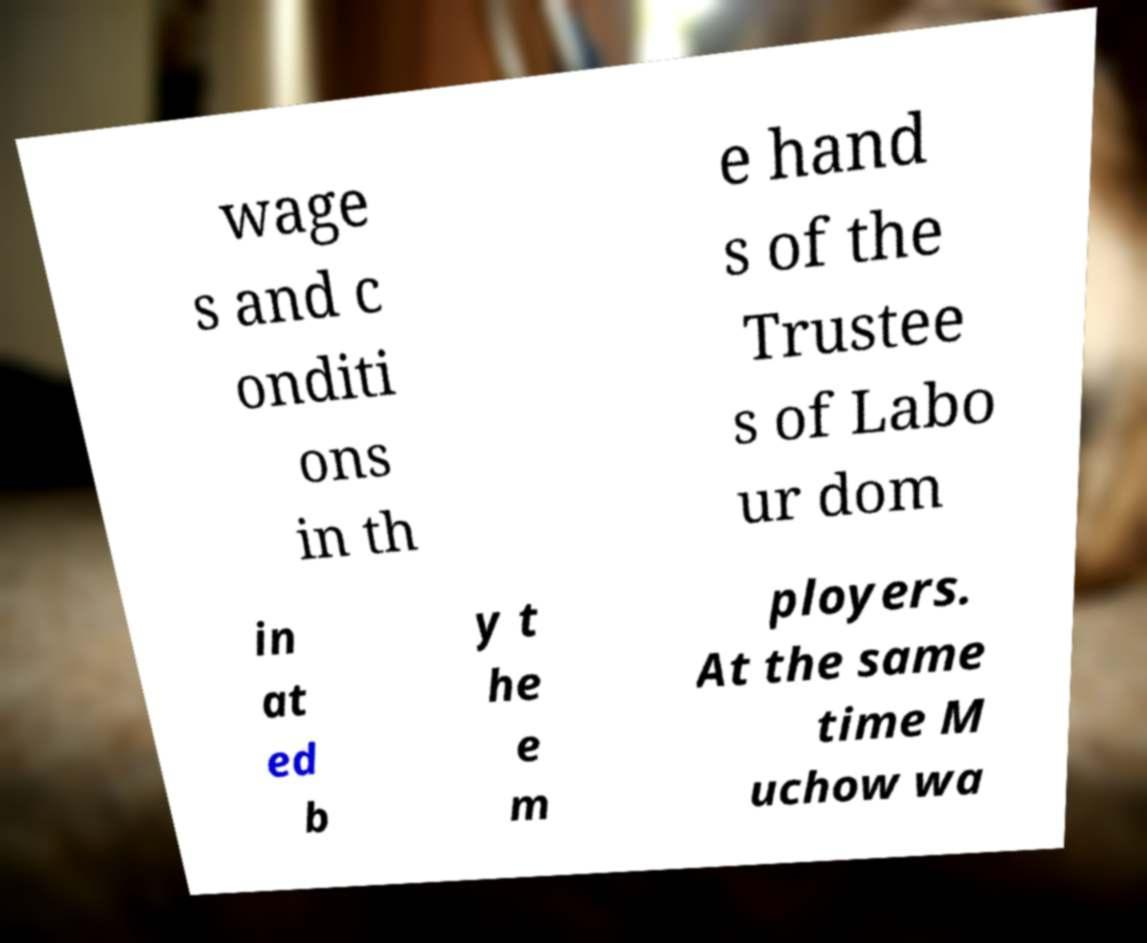Please identify and transcribe the text found in this image. wage s and c onditi ons in th e hand s of the Trustee s of Labo ur dom in at ed b y t he e m ployers. At the same time M uchow wa 